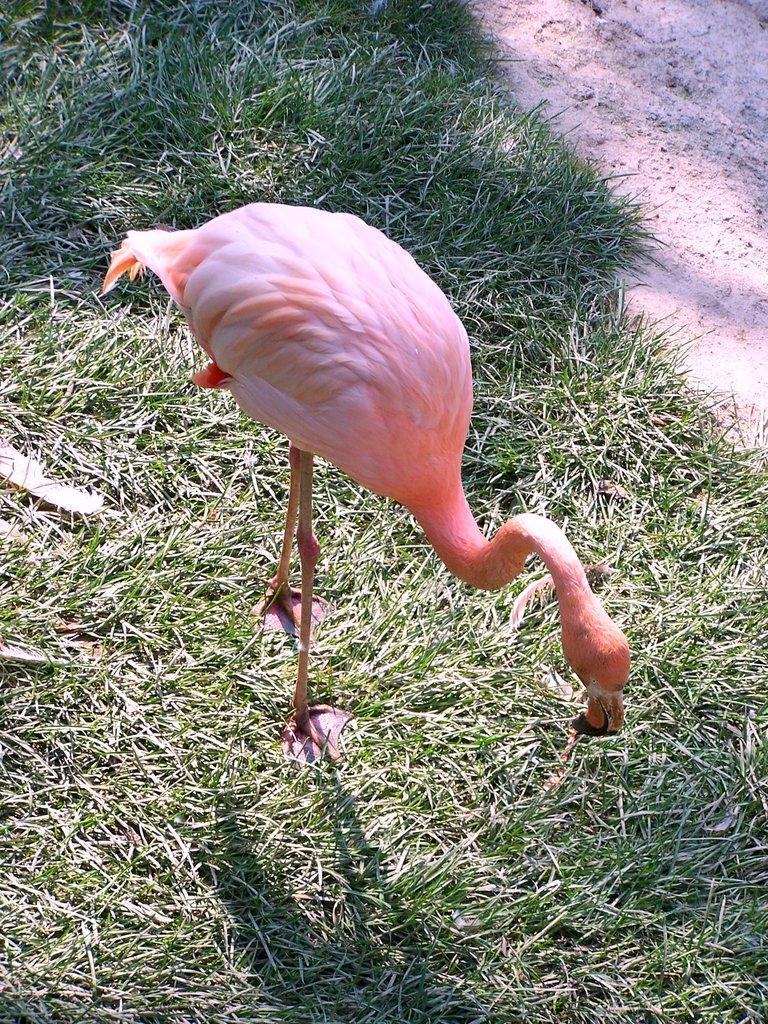What type of animal is in the image? There is a flamingo in the image. What is the flamingo doing in the image? The flamingo is standing on the ground. What type of terrain is visible in the image? There is grass on the ground. What type of plantation can be seen in the background of the image? There is no plantation visible in the image; it only features a flamingo standing on grass. How many ants are crawling on the flamingo's legs in the image? There are no ants present in the image. 